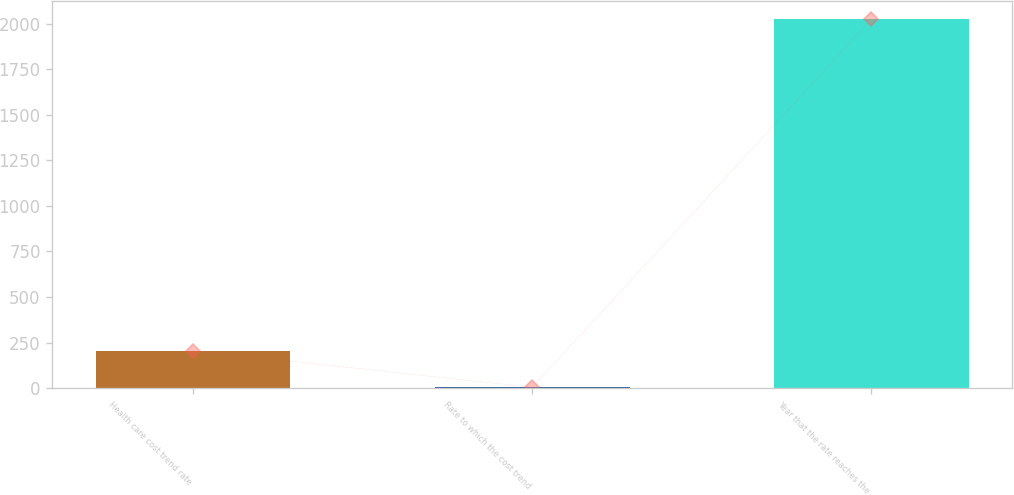Convert chart. <chart><loc_0><loc_0><loc_500><loc_500><bar_chart><fcel>Health care cost trend rate<fcel>Rate to which the cost trend<fcel>Year that the rate reaches the<nl><fcel>206.4<fcel>4.55<fcel>2023<nl></chart> 